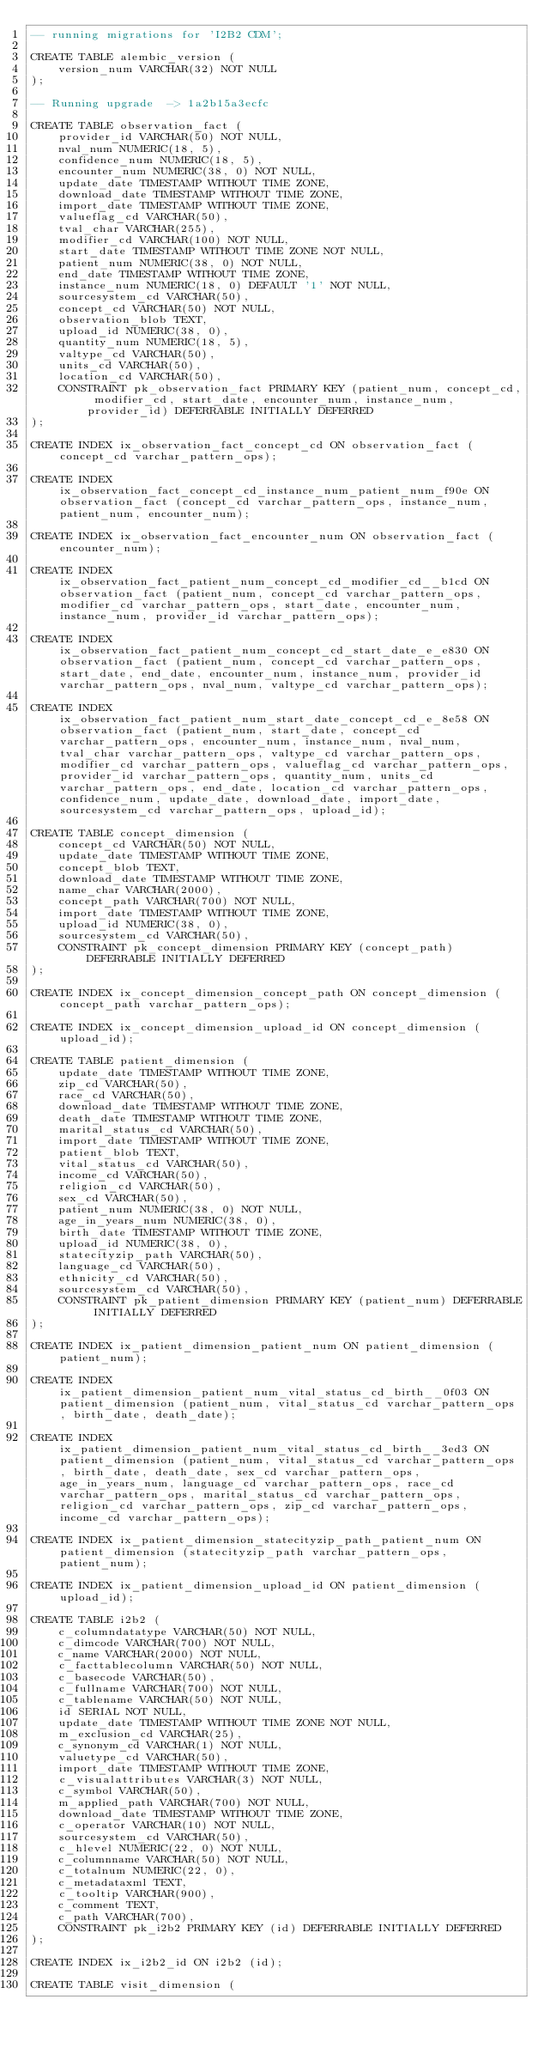<code> <loc_0><loc_0><loc_500><loc_500><_SQL_>-- running migrations for 'I2B2 CDM';

CREATE TABLE alembic_version (
    version_num VARCHAR(32) NOT NULL
);

-- Running upgrade  -> 1a2b15a3ecfc

CREATE TABLE observation_fact (
    provider_id VARCHAR(50) NOT NULL, 
    nval_num NUMERIC(18, 5), 
    confidence_num NUMERIC(18, 5), 
    encounter_num NUMERIC(38, 0) NOT NULL, 
    update_date TIMESTAMP WITHOUT TIME ZONE, 
    download_date TIMESTAMP WITHOUT TIME ZONE, 
    import_date TIMESTAMP WITHOUT TIME ZONE, 
    valueflag_cd VARCHAR(50), 
    tval_char VARCHAR(255), 
    modifier_cd VARCHAR(100) NOT NULL, 
    start_date TIMESTAMP WITHOUT TIME ZONE NOT NULL, 
    patient_num NUMERIC(38, 0) NOT NULL, 
    end_date TIMESTAMP WITHOUT TIME ZONE, 
    instance_num NUMERIC(18, 0) DEFAULT '1' NOT NULL, 
    sourcesystem_cd VARCHAR(50), 
    concept_cd VARCHAR(50) NOT NULL, 
    observation_blob TEXT, 
    upload_id NUMERIC(38, 0), 
    quantity_num NUMERIC(18, 5), 
    valtype_cd VARCHAR(50), 
    units_cd VARCHAR(50), 
    location_cd VARCHAR(50), 
    CONSTRAINT pk_observation_fact PRIMARY KEY (patient_num, concept_cd, modifier_cd, start_date, encounter_num, instance_num, provider_id) DEFERRABLE INITIALLY DEFERRED
);

CREATE INDEX ix_observation_fact_concept_cd ON observation_fact (concept_cd varchar_pattern_ops);

CREATE INDEX ix_observation_fact_concept_cd_instance_num_patient_num_f90e ON observation_fact (concept_cd varchar_pattern_ops, instance_num, patient_num, encounter_num);

CREATE INDEX ix_observation_fact_encounter_num ON observation_fact (encounter_num);

CREATE INDEX ix_observation_fact_patient_num_concept_cd_modifier_cd__b1cd ON observation_fact (patient_num, concept_cd varchar_pattern_ops, modifier_cd varchar_pattern_ops, start_date, encounter_num, instance_num, provider_id varchar_pattern_ops);

CREATE INDEX ix_observation_fact_patient_num_concept_cd_start_date_e_e830 ON observation_fact (patient_num, concept_cd varchar_pattern_ops, start_date, end_date, encounter_num, instance_num, provider_id varchar_pattern_ops, nval_num, valtype_cd varchar_pattern_ops);

CREATE INDEX ix_observation_fact_patient_num_start_date_concept_cd_e_8e58 ON observation_fact (patient_num, start_date, concept_cd varchar_pattern_ops, encounter_num, instance_num, nval_num, tval_char varchar_pattern_ops, valtype_cd varchar_pattern_ops, modifier_cd varchar_pattern_ops, valueflag_cd varchar_pattern_ops, provider_id varchar_pattern_ops, quantity_num, units_cd varchar_pattern_ops, end_date, location_cd varchar_pattern_ops, confidence_num, update_date, download_date, import_date, sourcesystem_cd varchar_pattern_ops, upload_id);

CREATE TABLE concept_dimension (
    concept_cd VARCHAR(50) NOT NULL, 
    update_date TIMESTAMP WITHOUT TIME ZONE, 
    concept_blob TEXT, 
    download_date TIMESTAMP WITHOUT TIME ZONE, 
    name_char VARCHAR(2000), 
    concept_path VARCHAR(700) NOT NULL, 
    import_date TIMESTAMP WITHOUT TIME ZONE, 
    upload_id NUMERIC(38, 0), 
    sourcesystem_cd VARCHAR(50), 
    CONSTRAINT pk_concept_dimension PRIMARY KEY (concept_path) DEFERRABLE INITIALLY DEFERRED
);

CREATE INDEX ix_concept_dimension_concept_path ON concept_dimension (concept_path varchar_pattern_ops);

CREATE INDEX ix_concept_dimension_upload_id ON concept_dimension (upload_id);

CREATE TABLE patient_dimension (
    update_date TIMESTAMP WITHOUT TIME ZONE, 
    zip_cd VARCHAR(50), 
    race_cd VARCHAR(50), 
    download_date TIMESTAMP WITHOUT TIME ZONE, 
    death_date TIMESTAMP WITHOUT TIME ZONE, 
    marital_status_cd VARCHAR(50), 
    import_date TIMESTAMP WITHOUT TIME ZONE, 
    patient_blob TEXT, 
    vital_status_cd VARCHAR(50), 
    income_cd VARCHAR(50), 
    religion_cd VARCHAR(50), 
    sex_cd VARCHAR(50), 
    patient_num NUMERIC(38, 0) NOT NULL, 
    age_in_years_num NUMERIC(38, 0), 
    birth_date TIMESTAMP WITHOUT TIME ZONE, 
    upload_id NUMERIC(38, 0), 
    statecityzip_path VARCHAR(50), 
    language_cd VARCHAR(50), 
    ethnicity_cd VARCHAR(50), 
    sourcesystem_cd VARCHAR(50), 
    CONSTRAINT pk_patient_dimension PRIMARY KEY (patient_num) DEFERRABLE INITIALLY DEFERRED
);

CREATE INDEX ix_patient_dimension_patient_num ON patient_dimension (patient_num);

CREATE INDEX ix_patient_dimension_patient_num_vital_status_cd_birth__0f03 ON patient_dimension (patient_num, vital_status_cd varchar_pattern_ops, birth_date, death_date);

CREATE INDEX ix_patient_dimension_patient_num_vital_status_cd_birth__3ed3 ON patient_dimension (patient_num, vital_status_cd varchar_pattern_ops, birth_date, death_date, sex_cd varchar_pattern_ops, age_in_years_num, language_cd varchar_pattern_ops, race_cd varchar_pattern_ops, marital_status_cd varchar_pattern_ops, religion_cd varchar_pattern_ops, zip_cd varchar_pattern_ops, income_cd varchar_pattern_ops);

CREATE INDEX ix_patient_dimension_statecityzip_path_patient_num ON patient_dimension (statecityzip_path varchar_pattern_ops, patient_num);

CREATE INDEX ix_patient_dimension_upload_id ON patient_dimension (upload_id);

CREATE TABLE i2b2 (
    c_columndatatype VARCHAR(50) NOT NULL, 
    c_dimcode VARCHAR(700) NOT NULL, 
    c_name VARCHAR(2000) NOT NULL, 
    c_facttablecolumn VARCHAR(50) NOT NULL, 
    c_basecode VARCHAR(50), 
    c_fullname VARCHAR(700) NOT NULL, 
    c_tablename VARCHAR(50) NOT NULL, 
    id SERIAL NOT NULL, 
    update_date TIMESTAMP WITHOUT TIME ZONE NOT NULL, 
    m_exclusion_cd VARCHAR(25), 
    c_synonym_cd VARCHAR(1) NOT NULL, 
    valuetype_cd VARCHAR(50), 
    import_date TIMESTAMP WITHOUT TIME ZONE, 
    c_visualattributes VARCHAR(3) NOT NULL, 
    c_symbol VARCHAR(50), 
    m_applied_path VARCHAR(700) NOT NULL, 
    download_date TIMESTAMP WITHOUT TIME ZONE, 
    c_operator VARCHAR(10) NOT NULL, 
    sourcesystem_cd VARCHAR(50), 
    c_hlevel NUMERIC(22, 0) NOT NULL, 
    c_columnname VARCHAR(50) NOT NULL, 
    c_totalnum NUMERIC(22, 0), 
    c_metadataxml TEXT, 
    c_tooltip VARCHAR(900), 
    c_comment TEXT, 
    c_path VARCHAR(700), 
    CONSTRAINT pk_i2b2 PRIMARY KEY (id) DEFERRABLE INITIALLY DEFERRED
);

CREATE INDEX ix_i2b2_id ON i2b2 (id);

CREATE TABLE visit_dimension (</code> 